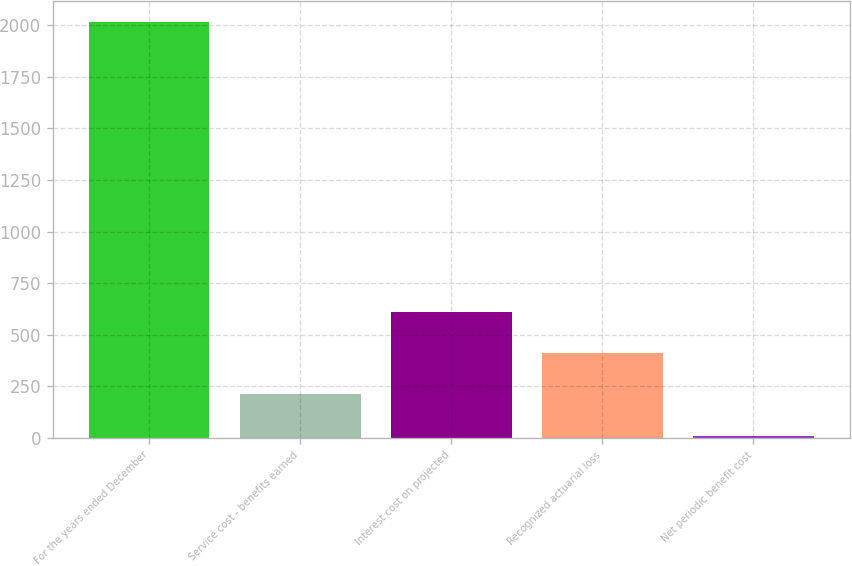Convert chart. <chart><loc_0><loc_0><loc_500><loc_500><bar_chart><fcel>For the years ended December<fcel>Service cost - benefits earned<fcel>Interest cost on projected<fcel>Recognized actuarial loss<fcel>Net periodic benefit cost<nl><fcel>2013<fcel>212.1<fcel>612.3<fcel>412.2<fcel>12<nl></chart> 